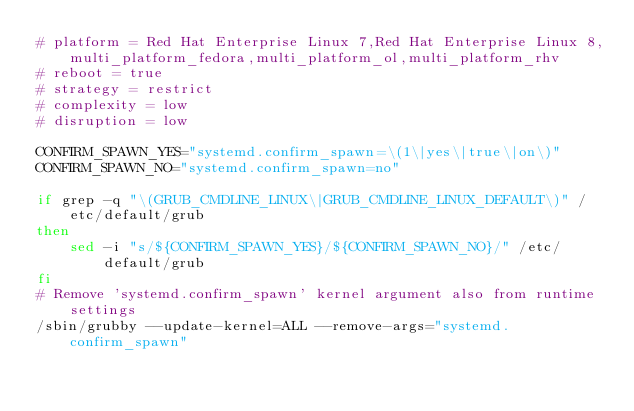<code> <loc_0><loc_0><loc_500><loc_500><_Bash_># platform = Red Hat Enterprise Linux 7,Red Hat Enterprise Linux 8,multi_platform_fedora,multi_platform_ol,multi_platform_rhv
# reboot = true
# strategy = restrict
# complexity = low
# disruption = low

CONFIRM_SPAWN_YES="systemd.confirm_spawn=\(1\|yes\|true\|on\)"
CONFIRM_SPAWN_NO="systemd.confirm_spawn=no"

if grep -q "\(GRUB_CMDLINE_LINUX\|GRUB_CMDLINE_LINUX_DEFAULT\)" /etc/default/grub
then
	sed -i "s/${CONFIRM_SPAWN_YES}/${CONFIRM_SPAWN_NO}/" /etc/default/grub
fi
# Remove 'systemd.confirm_spawn' kernel argument also from runtime settings
/sbin/grubby --update-kernel=ALL --remove-args="systemd.confirm_spawn"
</code> 